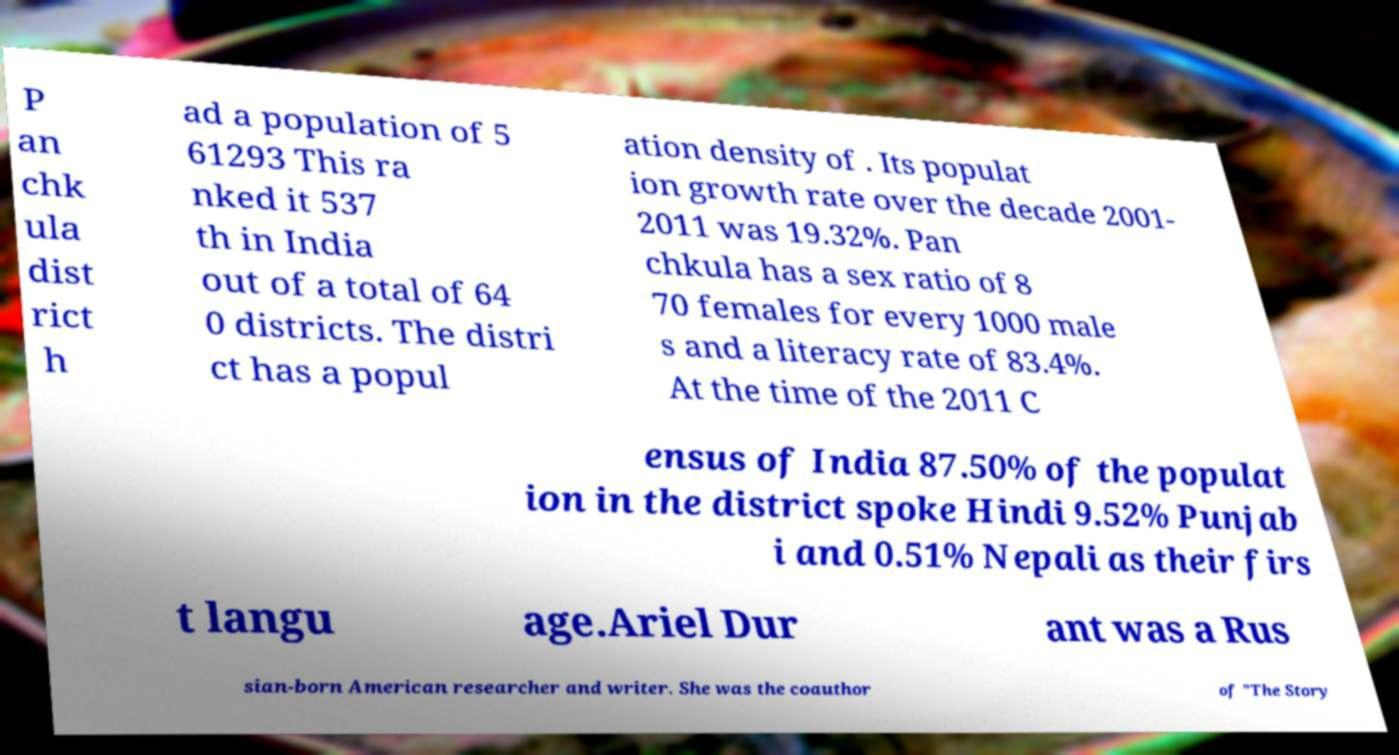I need the written content from this picture converted into text. Can you do that? P an chk ula dist rict h ad a population of 5 61293 This ra nked it 537 th in India out of a total of 64 0 districts. The distri ct has a popul ation density of . Its populat ion growth rate over the decade 2001- 2011 was 19.32%. Pan chkula has a sex ratio of 8 70 females for every 1000 male s and a literacy rate of 83.4%. At the time of the 2011 C ensus of India 87.50% of the populat ion in the district spoke Hindi 9.52% Punjab i and 0.51% Nepali as their firs t langu age.Ariel Dur ant was a Rus sian-born American researcher and writer. She was the coauthor of "The Story 